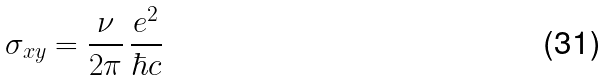Convert formula to latex. <formula><loc_0><loc_0><loc_500><loc_500>\sigma _ { x y } = \frac { \nu } { 2 \pi } \, \frac { e ^ { 2 } } { \hbar { c } }</formula> 